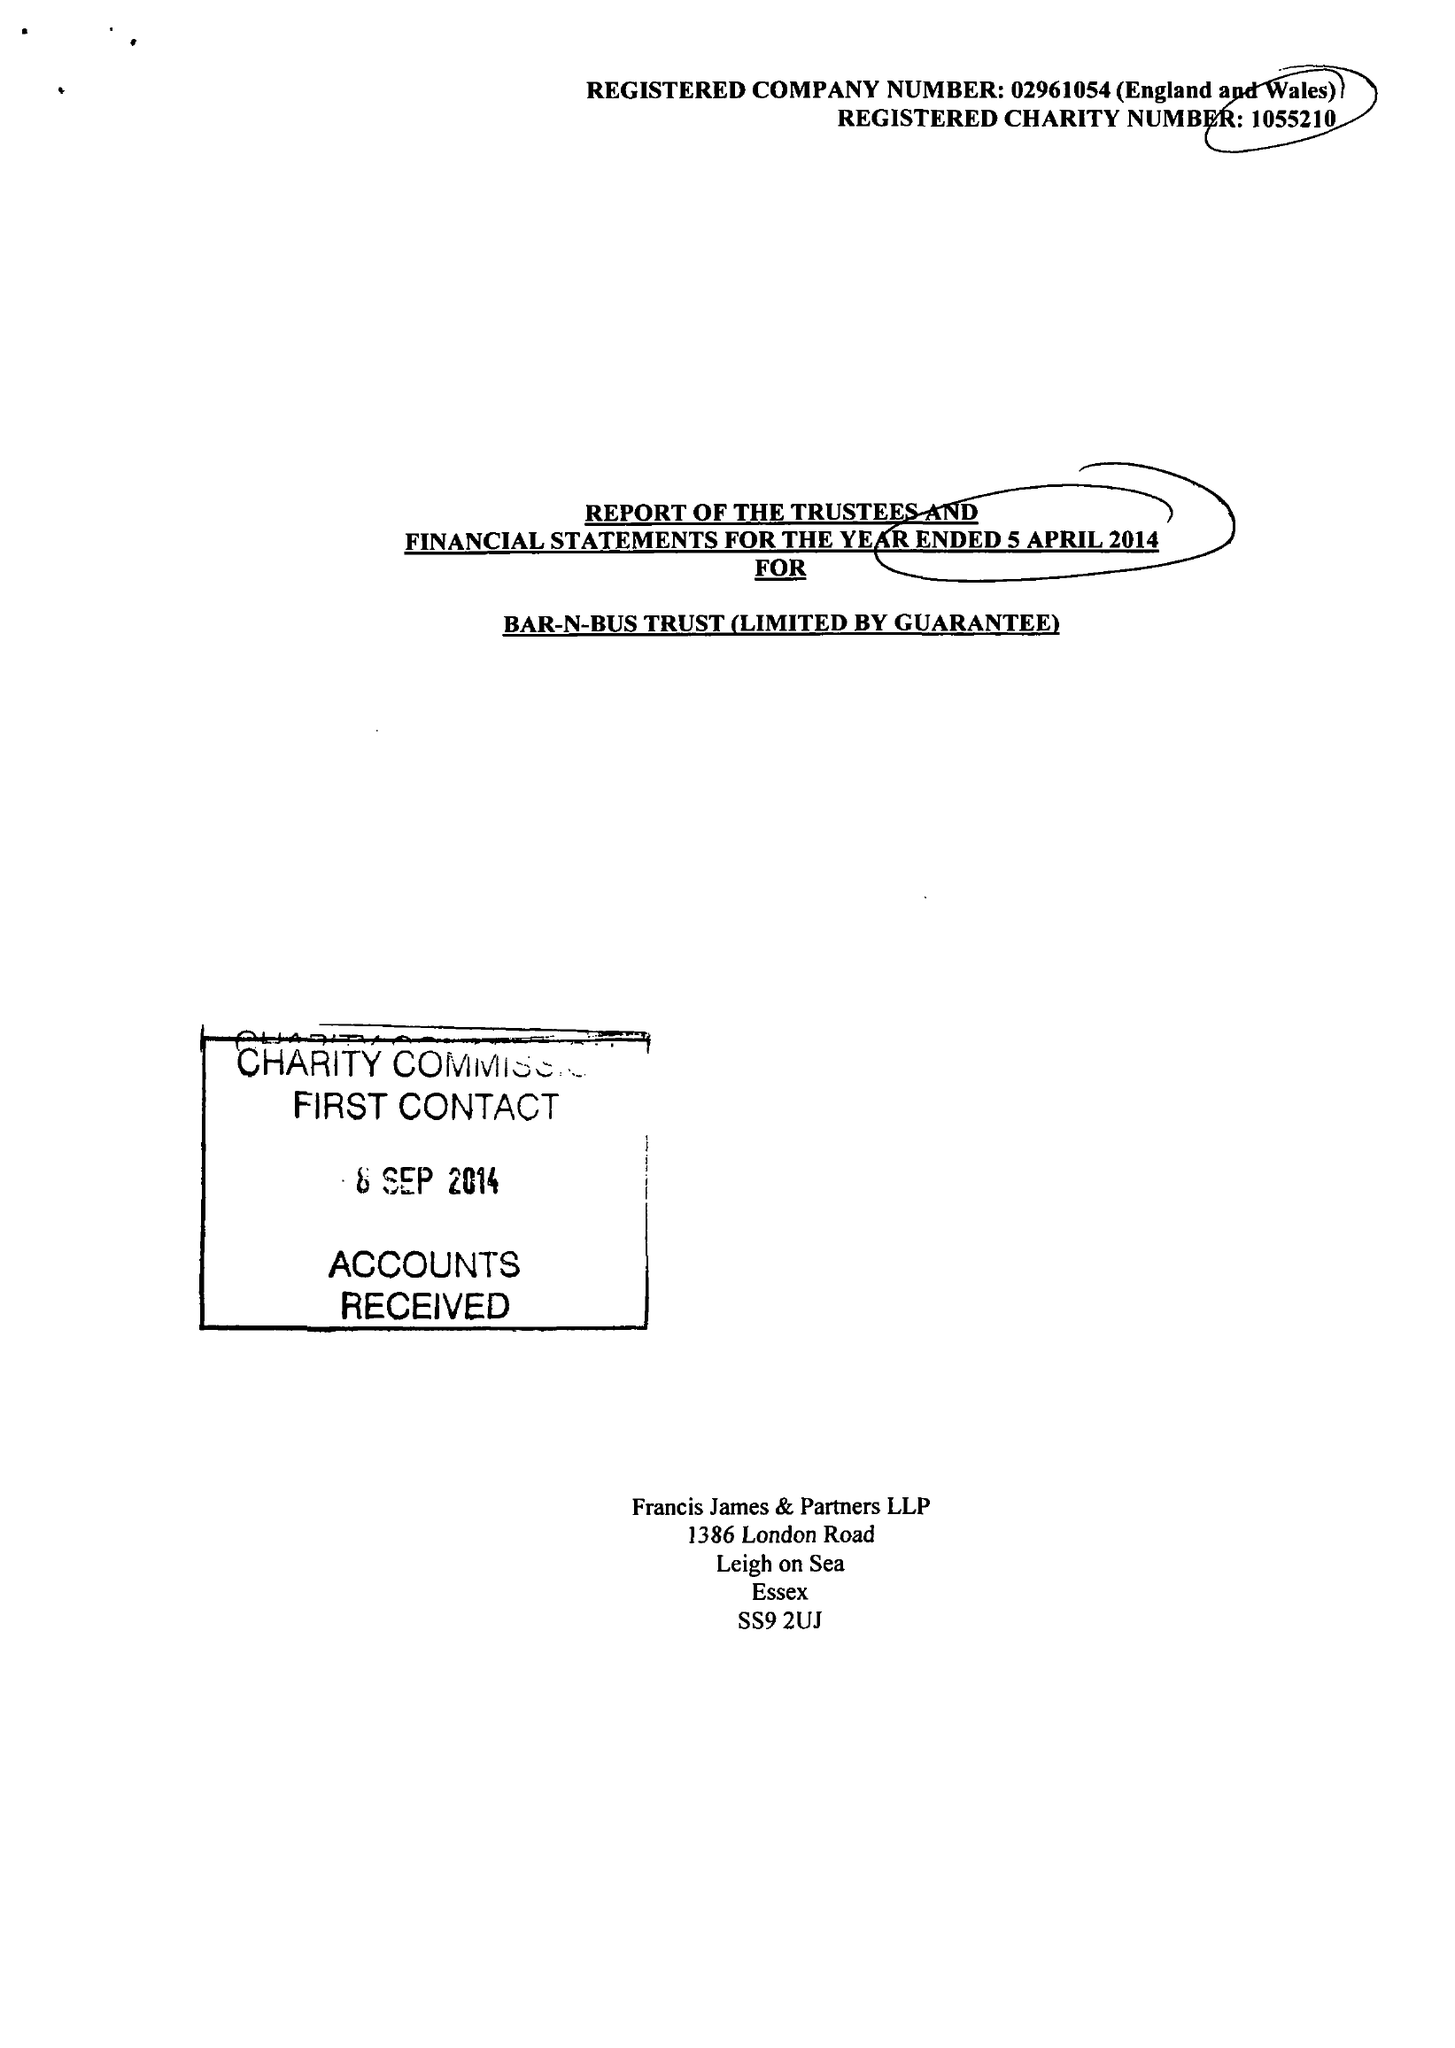What is the value for the spending_annually_in_british_pounds?
Answer the question using a single word or phrase. 108292.00 